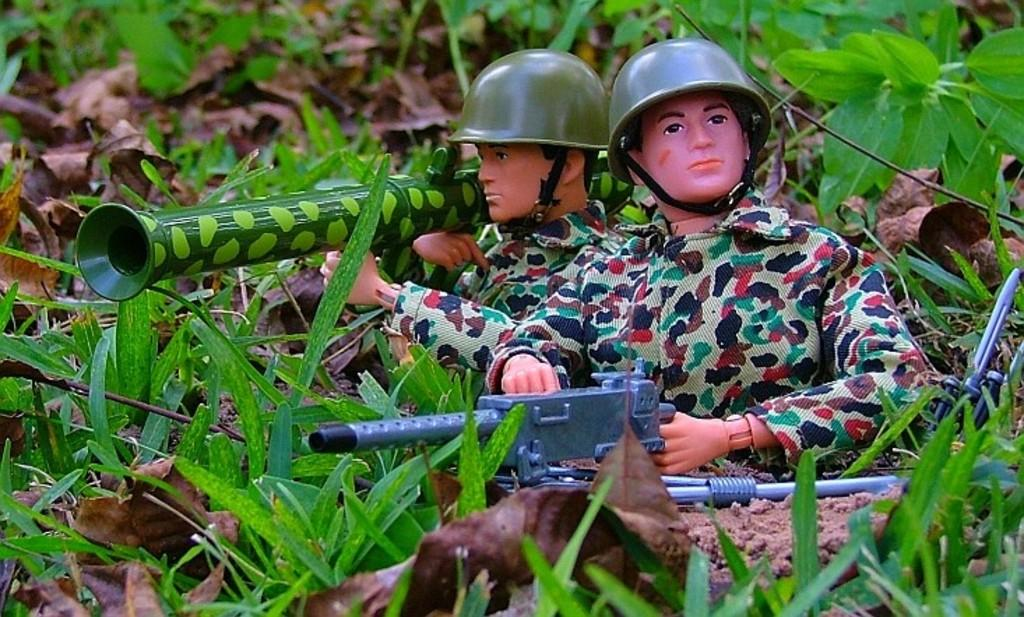How many dolls are in the image? There are two dolls in the image. What are the dolls holding in their hands? The dolls are holding guns. What type of vegetation is present in the image? There are plants and leaves in the image. What material is on the floor in the image? There is sand on the floor in the image. What type of spoon is being used to expand the plants in the image? There is no spoon or expansion of plants present in the image. 